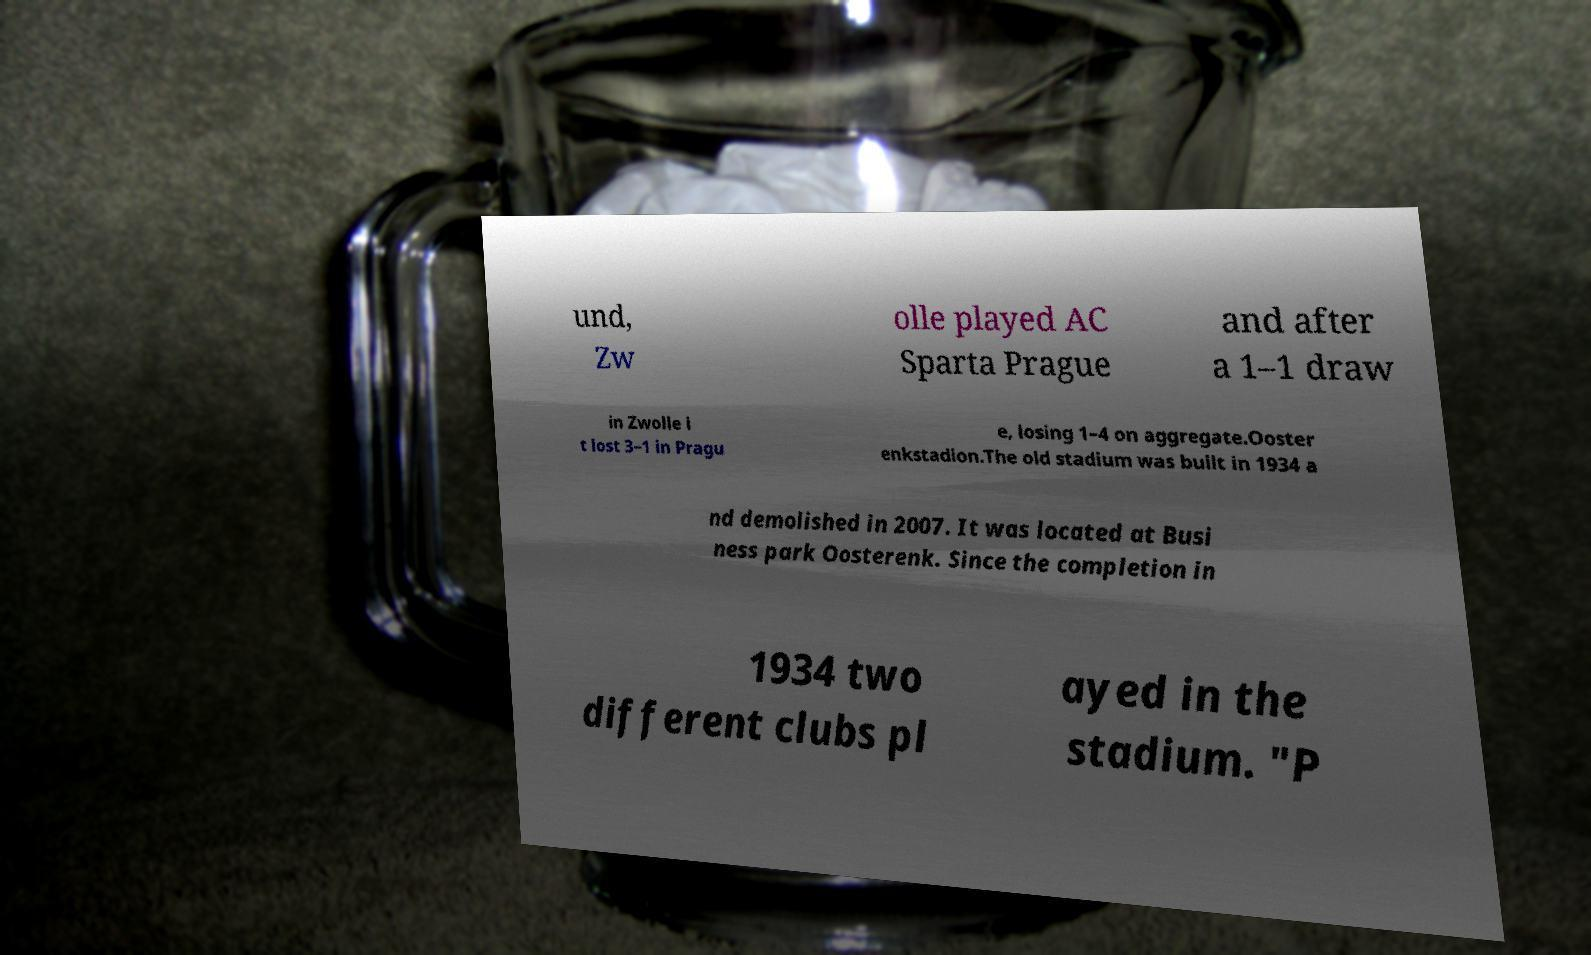Can you accurately transcribe the text from the provided image for me? und, Zw olle played AC Sparta Prague and after a 1–1 draw in Zwolle i t lost 3–1 in Pragu e, losing 1–4 on aggregate.Ooster enkstadion.The old stadium was built in 1934 a nd demolished in 2007. It was located at Busi ness park Oosterenk. Since the completion in 1934 two different clubs pl ayed in the stadium. "P 